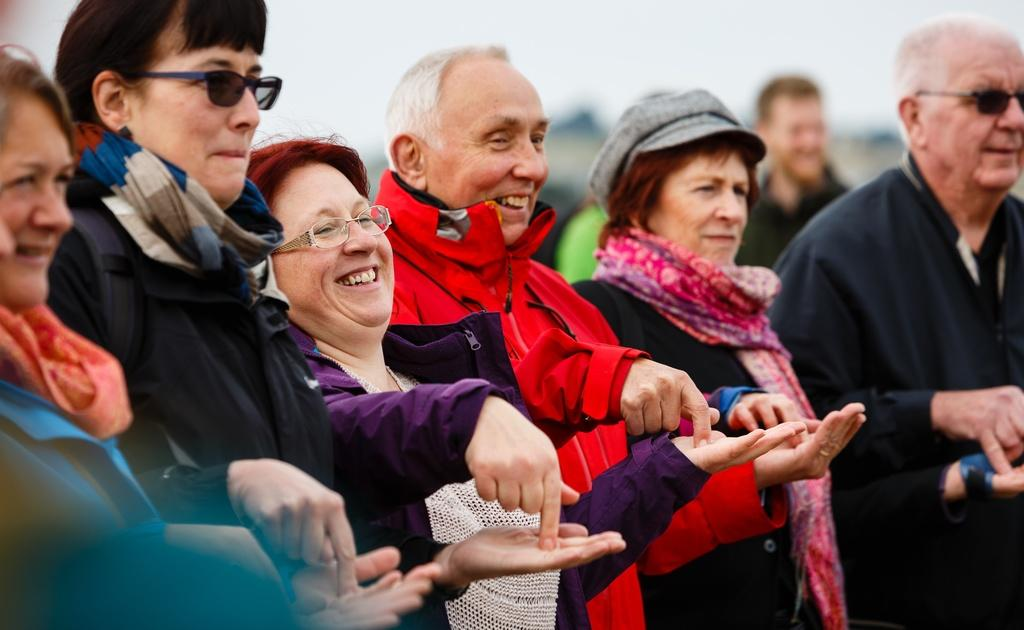How many people are in the image? There are people in the image, but the exact number is not specified. What are the people doing in the image? The people are standing in the image. What is the emotional expression of the people in the image? The people are smiling in the image. What type of form can be seen in the cellar of the prison in the image? There is no mention of a form, cellar, or prison in the image. The image only features people who are standing and smiling. 